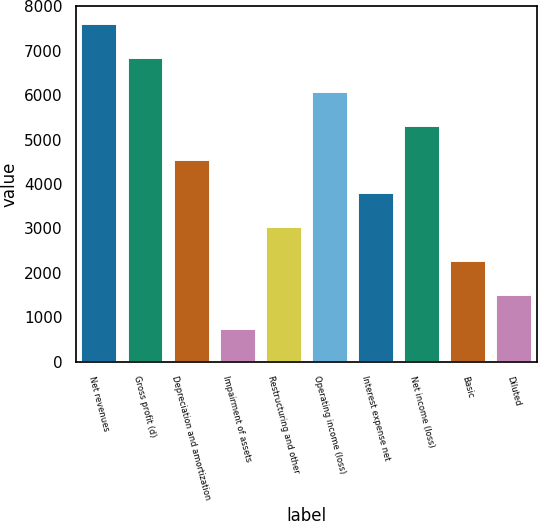Convert chart. <chart><loc_0><loc_0><loc_500><loc_500><bar_chart><fcel>Net revenues<fcel>Gross profit (d)<fcel>Depreciation and amortization<fcel>Impairment of assets<fcel>Restructuring and other<fcel>Operating income (loss)<fcel>Interest expense net<fcel>Net income (loss)<fcel>Basic<fcel>Diluted<nl><fcel>7620.3<fcel>6858.45<fcel>4572.91<fcel>763.7<fcel>3049.23<fcel>6096.61<fcel>3811.07<fcel>5334.76<fcel>2287.39<fcel>1525.55<nl></chart> 